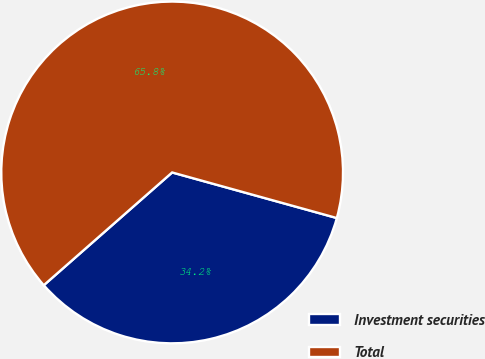Convert chart. <chart><loc_0><loc_0><loc_500><loc_500><pie_chart><fcel>Investment securities<fcel>Total<nl><fcel>34.23%<fcel>65.77%<nl></chart> 